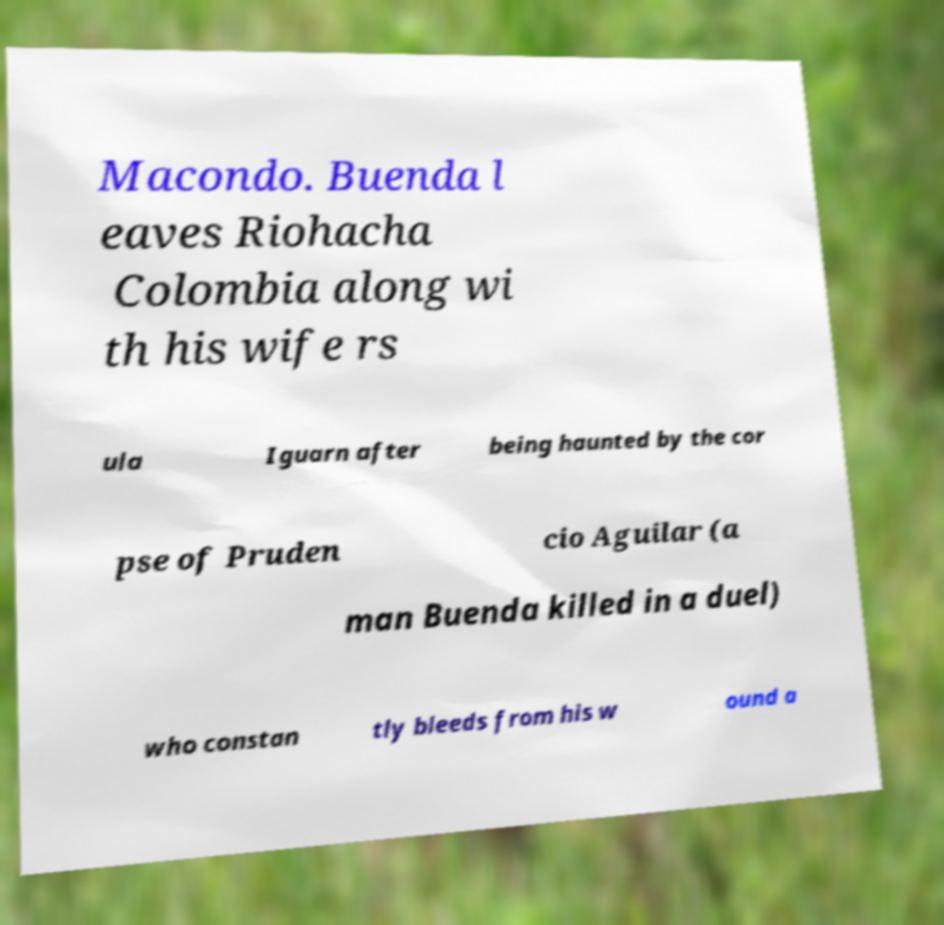Please identify and transcribe the text found in this image. Macondo. Buenda l eaves Riohacha Colombia along wi th his wife rs ula Iguarn after being haunted by the cor pse of Pruden cio Aguilar (a man Buenda killed in a duel) who constan tly bleeds from his w ound a 